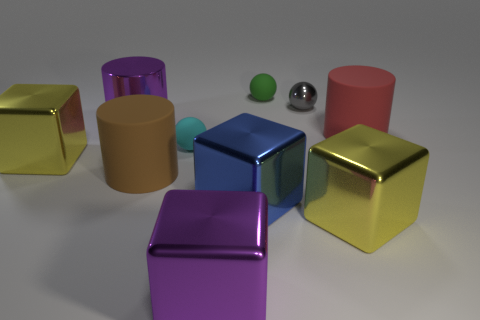Subtract all cyan rubber balls. How many balls are left? 2 Subtract all blue cubes. How many cubes are left? 3 Subtract all blocks. How many objects are left? 6 Subtract all blue cubes. Subtract all cyan cylinders. How many cubes are left? 3 Add 7 large brown cylinders. How many large brown cylinders are left? 8 Add 3 tiny gray metallic balls. How many tiny gray metallic balls exist? 4 Subtract 0 gray cylinders. How many objects are left? 10 Subtract all tiny rubber spheres. Subtract all cyan objects. How many objects are left? 7 